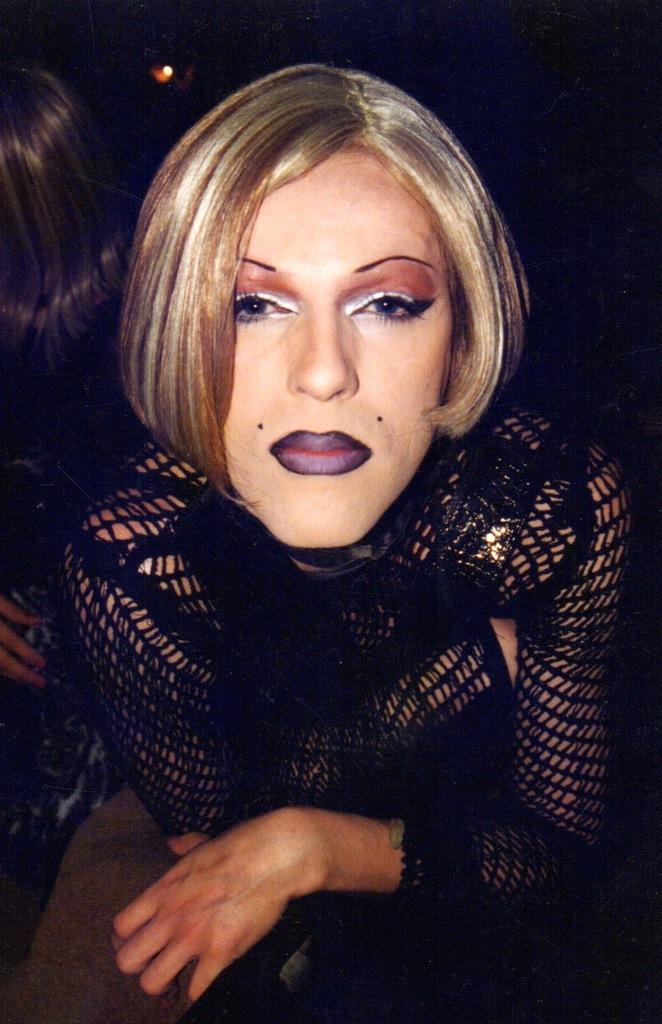What is the woman in the middle of the image wearing? The woman in the middle of the image is wearing a black dress. What is the woman in the middle of the image doing? The woman is watching something. Can you describe the other woman in the image? There is another woman in the background of the image. What can be seen in the background of the image? There is light in the background, and the background is dark in color. What type of lipstick is the woman in the background wearing in the image? There is no information about lipstick or the woman in the background wearing any in the image. 